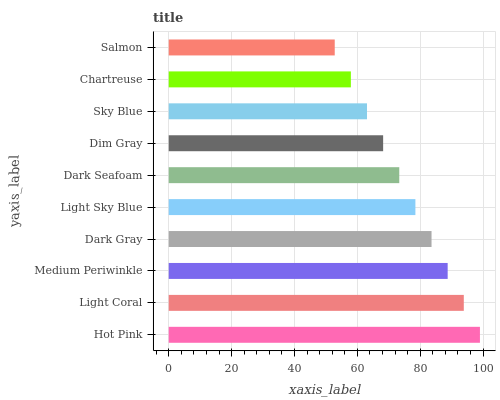Is Salmon the minimum?
Answer yes or no. Yes. Is Hot Pink the maximum?
Answer yes or no. Yes. Is Light Coral the minimum?
Answer yes or no. No. Is Light Coral the maximum?
Answer yes or no. No. Is Hot Pink greater than Light Coral?
Answer yes or no. Yes. Is Light Coral less than Hot Pink?
Answer yes or no. Yes. Is Light Coral greater than Hot Pink?
Answer yes or no. No. Is Hot Pink less than Light Coral?
Answer yes or no. No. Is Light Sky Blue the high median?
Answer yes or no. Yes. Is Dark Seafoam the low median?
Answer yes or no. Yes. Is Dark Seafoam the high median?
Answer yes or no. No. Is Chartreuse the low median?
Answer yes or no. No. 